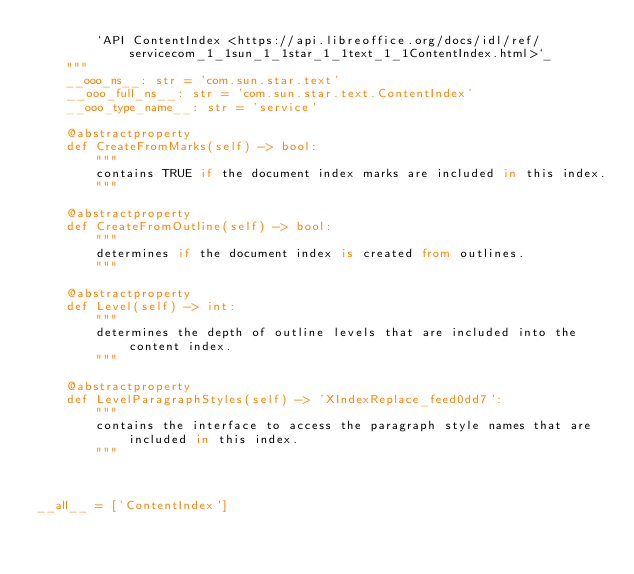Convert code to text. <code><loc_0><loc_0><loc_500><loc_500><_Python_>        `API ContentIndex <https://api.libreoffice.org/docs/idl/ref/servicecom_1_1sun_1_1star_1_1text_1_1ContentIndex.html>`_
    """
    __ooo_ns__: str = 'com.sun.star.text'
    __ooo_full_ns__: str = 'com.sun.star.text.ContentIndex'
    __ooo_type_name__: str = 'service'

    @abstractproperty
    def CreateFromMarks(self) -> bool:
        """
        contains TRUE if the document index marks are included in this index.
        """

    @abstractproperty
    def CreateFromOutline(self) -> bool:
        """
        determines if the document index is created from outlines.
        """

    @abstractproperty
    def Level(self) -> int:
        """
        determines the depth of outline levels that are included into the content index.
        """

    @abstractproperty
    def LevelParagraphStyles(self) -> 'XIndexReplace_feed0dd7':
        """
        contains the interface to access the paragraph style names that are included in this index.
        """



__all__ = ['ContentIndex']

</code> 